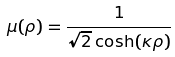<formula> <loc_0><loc_0><loc_500><loc_500>\mu ( \rho ) = \frac { 1 } { \sqrt { 2 } \cosh ( \kappa \rho ) }</formula> 